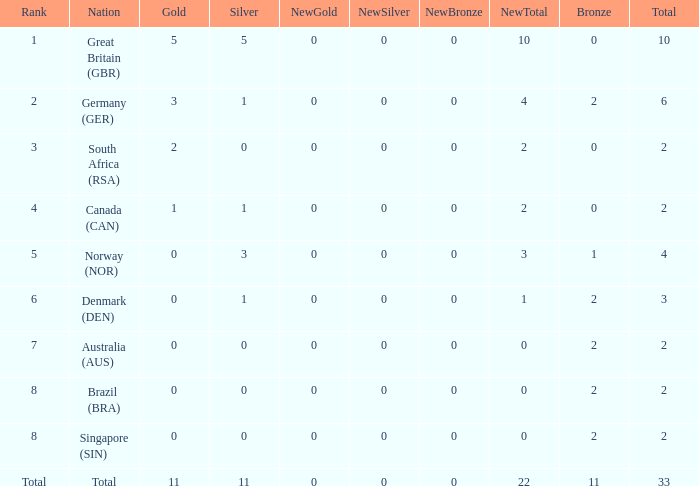What is the least total when the nation is canada (can) and bronze is less than 0? None. 